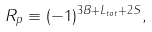<formula> <loc_0><loc_0><loc_500><loc_500>R _ { p } \equiv ( - 1 ) ^ { 3 B + L _ { t o t } + 2 S } ,</formula> 